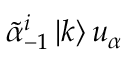Convert formula to latex. <formula><loc_0><loc_0><loc_500><loc_500>\tilde { \alpha } _ { - 1 } ^ { i } \left | k \right > u _ { \alpha }</formula> 